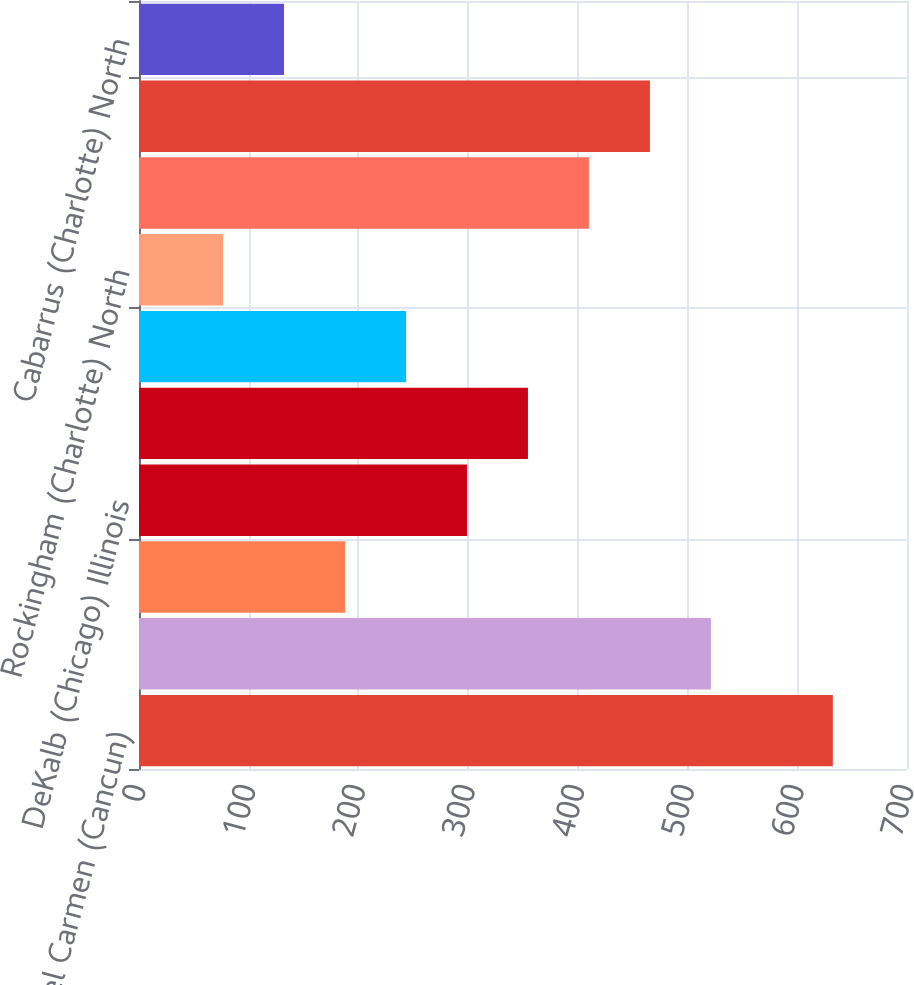Convert chart to OTSL. <chart><loc_0><loc_0><loc_500><loc_500><bar_chart><fcel>Playa del Carmen (Cancun)<fcel>Hanover (Harrisburg)<fcel>McCook (Chicago) Illinois<fcel>DeKalb (Chicago) Illinois<fcel>Gold Hill (Charlotte) North<fcel>Macon Georgia<fcel>Rockingham (Charlotte) North<fcel>Norcross (Atlanta) Georgia<fcel>1604 Stone (San Antonio) Texas<fcel>Cabarrus (Charlotte) North<nl><fcel>632.4<fcel>521.24<fcel>187.76<fcel>298.92<fcel>354.5<fcel>243.34<fcel>76.6<fcel>410.08<fcel>465.66<fcel>132.18<nl></chart> 